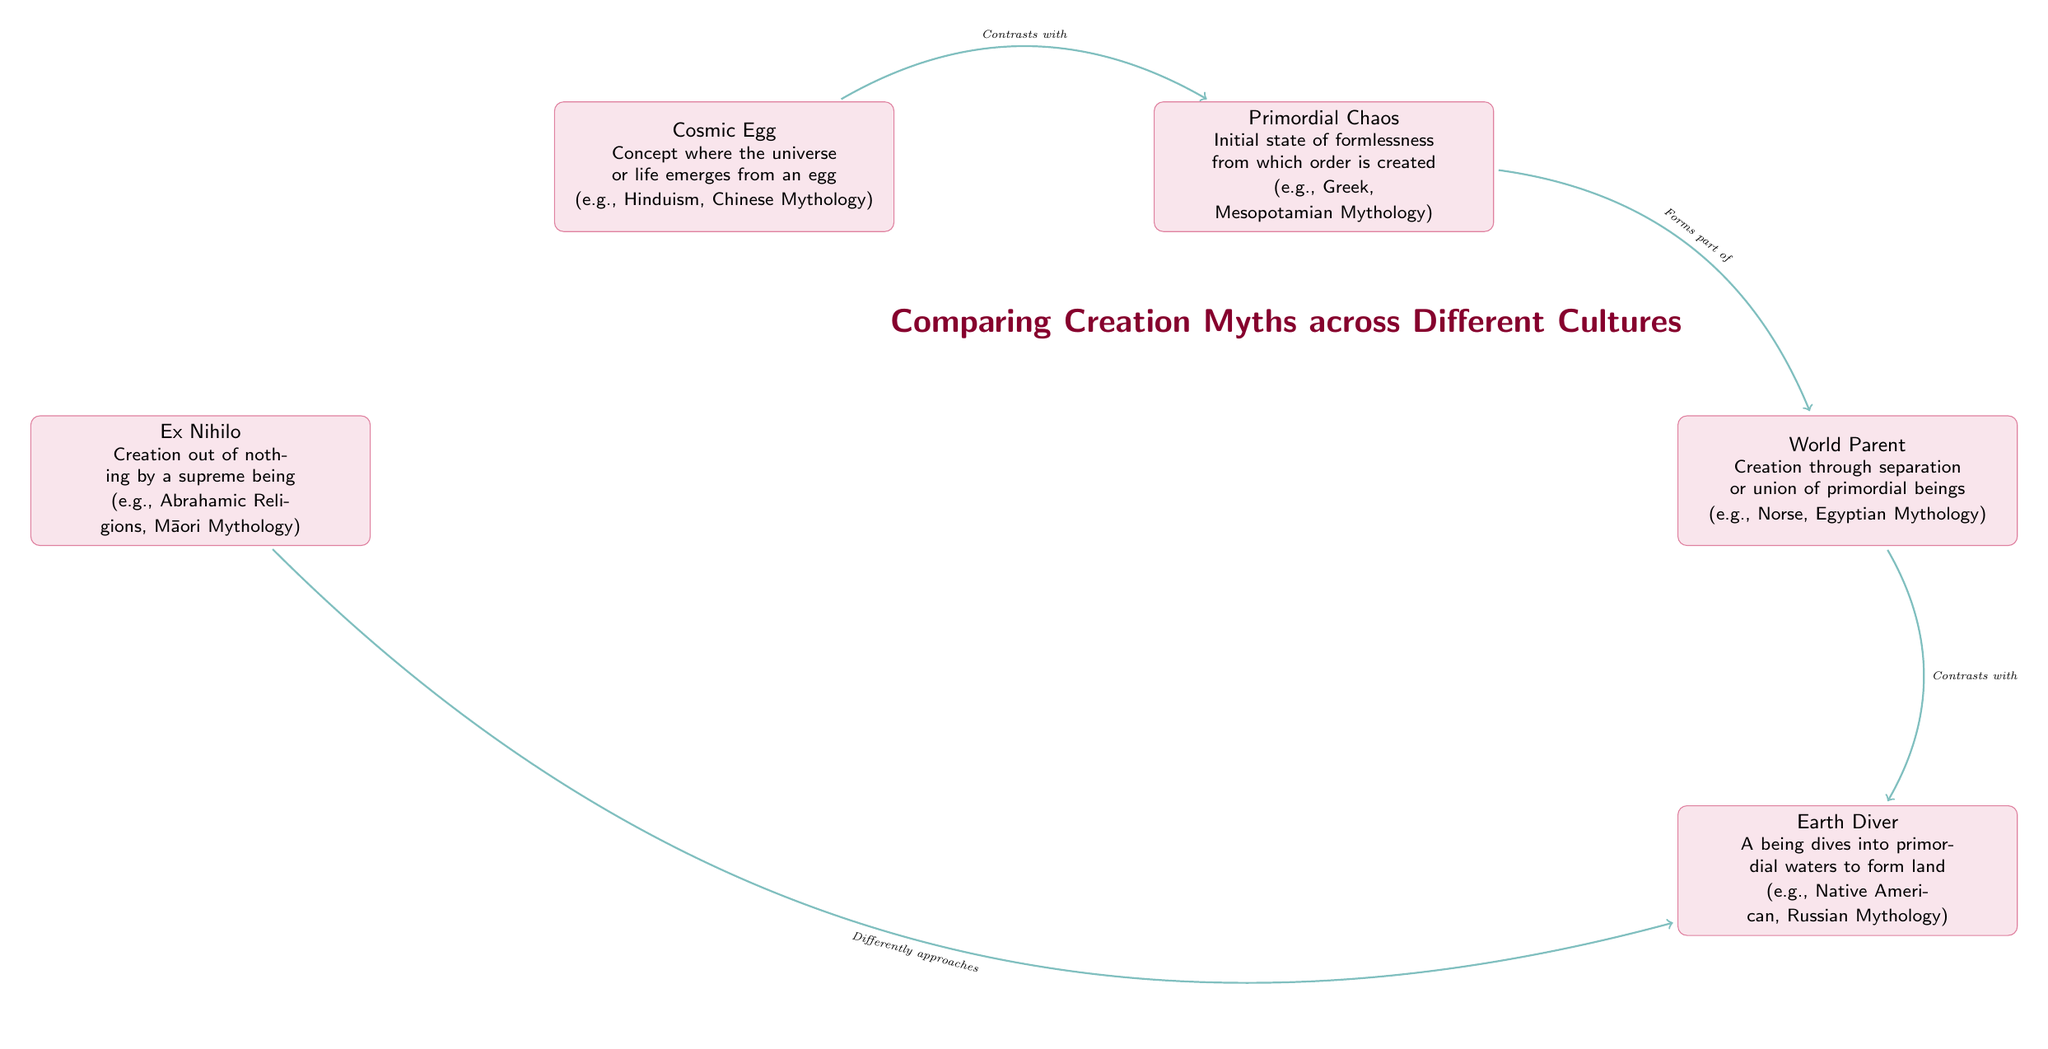What is the concept represented by the node "Cosmic Egg"? The node "Cosmic Egg" describes the concept where the universe or life emerges from an egg. This information is found directly in the content of the node.
Answer: Concept where the universe or life emerges from an egg Which two myths are examples of "Primordial Chaos"? The examples listed under the "Primordial Chaos" node are Greek Mythology and Mesopotamian Mythology. By examining this node, we can identify the references to these specific cultures.
Answer: Greek Mythology (Chaos), Mesopotamian Mythology (Tiamat) How many nodes are present in the diagram? By counting all the distinct creations myths represented in the nodes, we find a total of five nodes listed. This includes Cosmic Egg, Primordial Chaos, World Parent, Ex Nihilo, and Earth Diver.
Answer: 5 What relationship exists between "Chaos" and "World Parent"? The relationship between "Chaos" and "World Parent" is indicated by the text “Forms part of”, which defines the connection outlined in the diagram.
Answer: Forms part of Which creation myth contrasts with "Earth Diver"? The node "World Parent" is shown with a relationship that states it contrasts with "Earth Diver", indicating a notable distinction between these two concepts in the flow chart.
Answer: World Parent What is the common theme among the examples listed under "Ex Nihilo"? The examples under the "Ex Nihilo" node include Abrahamic Religions and Māori Mythology, which both showcase creation occurring out of nothing by a deity, reflecting a shared theme of divine creation.
Answer: Creation out of nothing What does "Cosmic Egg" contrast with? The edge connecting "Cosmic Egg" to "Primordial Chaos" indicates the contrasting relationship, showing how these two distinct creation concepts are related within the chart.
Answer: Primordial Chaos Which node talks about a supreme being or deity? The "Ex Nihilo" node specifically addresses the theme of creation that involves a supreme being or deity, as illustrated in its content.
Answer: Ex Nihilo 